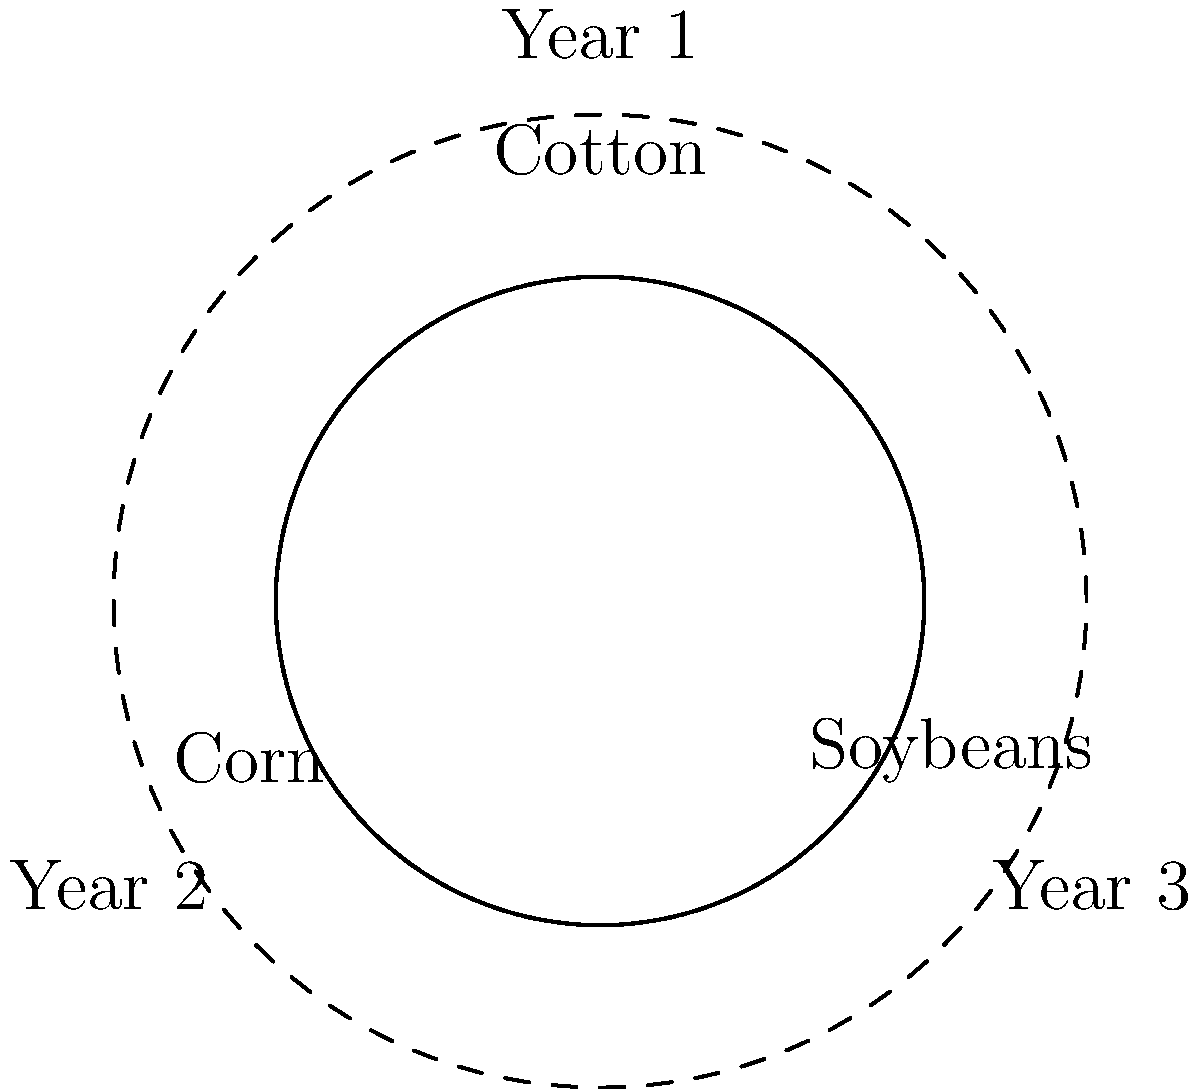In Southern agriculture, a common crop rotation pattern involves cycling through cotton, corn, and soybeans over a three-year period. This rotation can be modeled using a cyclic group of order 3. If we define the operation as "rotate to the next crop in the sequence," how many distinct elements are in the group generated by this operation, and what is the order of the generator element? To solve this problem, let's analyze the crop rotation pattern step-by-step:

1. The given rotation pattern is Cotton → Corn → Soybeans → Cotton (repeat).

2. Let's define our group operation as "rotate to the next crop in the sequence." We can call this operation $r$.

3. The elements of our group are:
   - Identity element (e): No rotation (stay on the same crop)
   - $r$: Rotate once (e.g., Cotton to Corn)
   - $r^2$: Rotate twice (e.g., Cotton to Soybeans)

4. Applying $r$ three times brings us back to the starting position: $r^3 = e$

5. The distinct elements in the group are: $\{e, r, r^2\}$

6. The number of distinct elements is 3, which is also the order of the group.

7. The generator of this group is $r$, as repeated application of $r$ generates all elements of the group.

8. The order of the generator $r$ is 3, because $r^3 = e$ (the identity element).

Therefore, the group generated by this operation has 3 distinct elements, and the order of the generator element is 3.
Answer: 3 distinct elements; order of generator is 3 